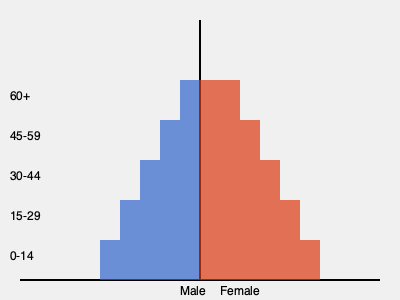As a political analyst, how would you interpret this population pyramid in terms of its potential impact on future election outcomes, particularly considering the differences between male and female populations in various age groups? To interpret this population pyramid and its potential impact on future election outcomes, we need to consider several factors:

1. Age distribution:
   - The pyramid shows a broader base, indicating a younger population.
   - There's a gradual decrease in population as age increases.

2. Gender differences:
   - The female population (right side) is larger than the male population (left side) in all age groups.
   - This difference is most pronounced in the older age groups (45-59 and 60+).

3. Voting patterns by age:
   - Younger voters (15-29 and 30-44) tend to have lower turnout rates but are more likely to support progressive policies.
   - Middle-aged and older voters (45-59 and 60+) typically have higher turnout rates and may lean more conservative.

4. Gender voting trends:
   - Women, especially in recent years, have shown a tendency to vote more for left-leaning or progressive candidates.
   - The larger female population, particularly in older age groups, could significantly influence election outcomes.

5. Future projections:
   - The broad base of young people suggests a growing electorate in the coming years.
   - As the younger population ages, their political preferences may shift, potentially changing the political landscape.

6. Policy implications:
   - The large young population might prioritize issues like education, job creation, and climate change.
   - The significant older female population might emphasize healthcare, social security, and gender equality issues.

7. Campaign strategies:
   - Candidates might tailor their messages to appeal to the larger female demographic across all age groups.
   - There may be a focus on engaging the youth vote, given their potential to swing elections as they age and become more politically active.

8. Long-term political shifts:
   - The demographic structure suggests a potential for gradual political change as the younger, more numerous cohorts age and become a larger part of the active electorate.

Given these factors, future elections could see a trend towards more progressive policies and candidates, particularly those that appeal to women and younger voters. However, the high turnout rates of older voters could still maintain a strong influence from more conservative viewpoints in the short to medium term.
Answer: Potential shift towards progressive policies due to large young population and female majority, balanced by high turnout of older voters. 